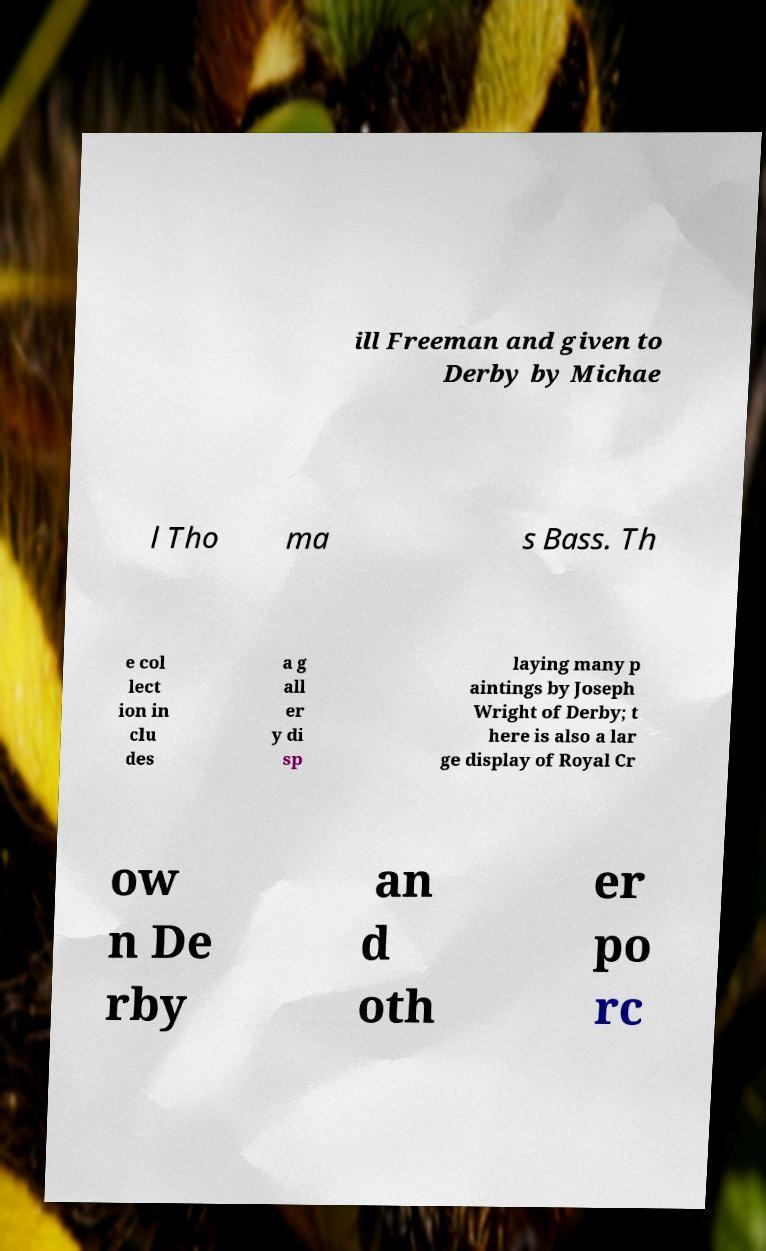I need the written content from this picture converted into text. Can you do that? ill Freeman and given to Derby by Michae l Tho ma s Bass. Th e col lect ion in clu des a g all er y di sp laying many p aintings by Joseph Wright of Derby; t here is also a lar ge display of Royal Cr ow n De rby an d oth er po rc 